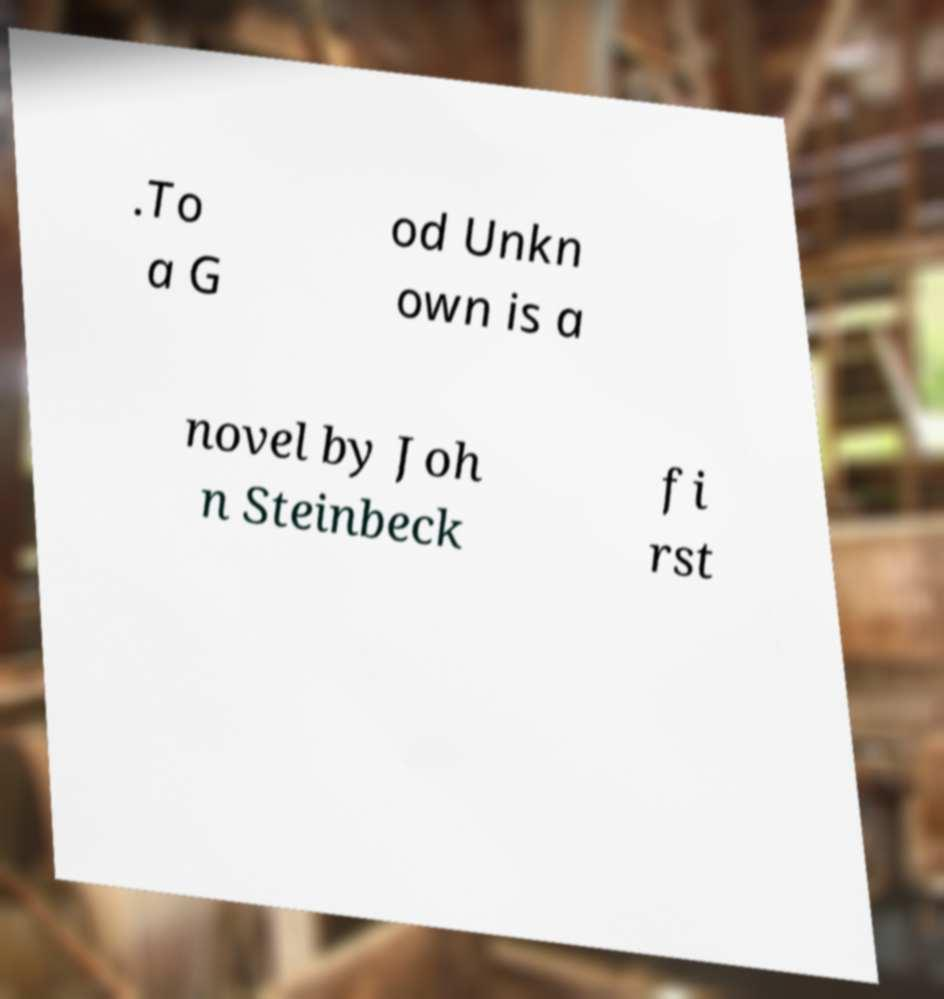Can you accurately transcribe the text from the provided image for me? .To a G od Unkn own is a novel by Joh n Steinbeck fi rst 